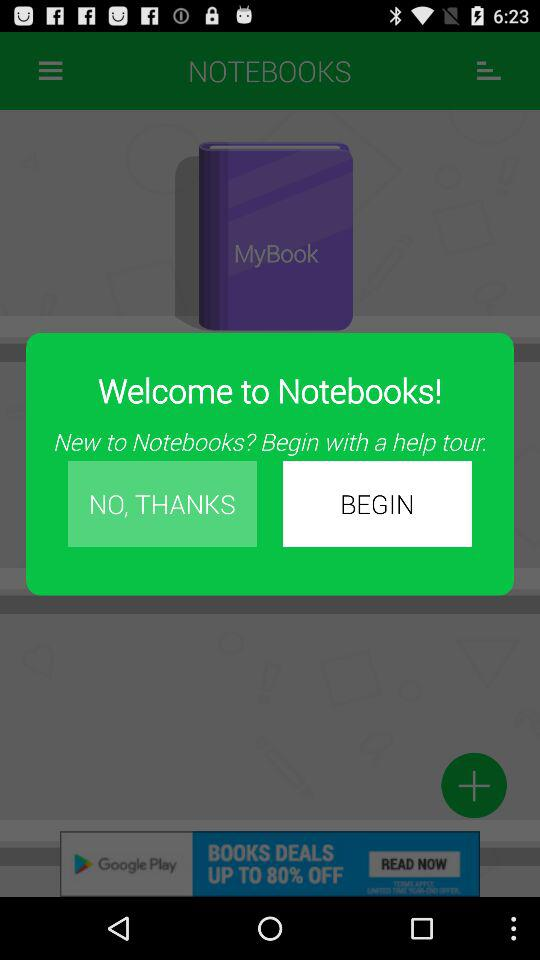What is the application name? The application name is "NOTEBOOKS". 